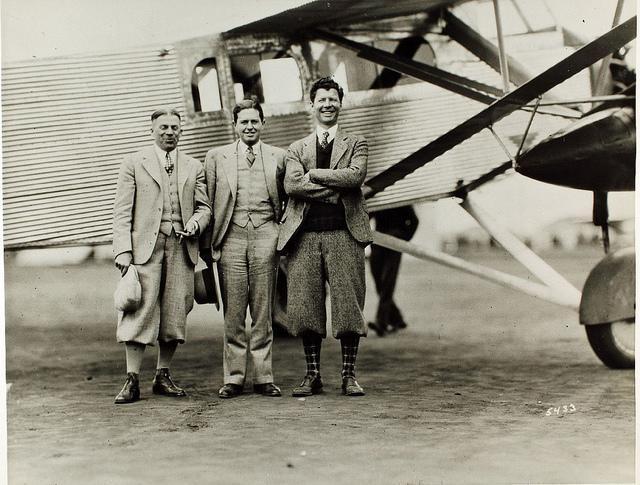How many men are shown?
Give a very brief answer. 3. How many people can be seen?
Give a very brief answer. 4. How many bottles are missing?
Give a very brief answer. 0. 